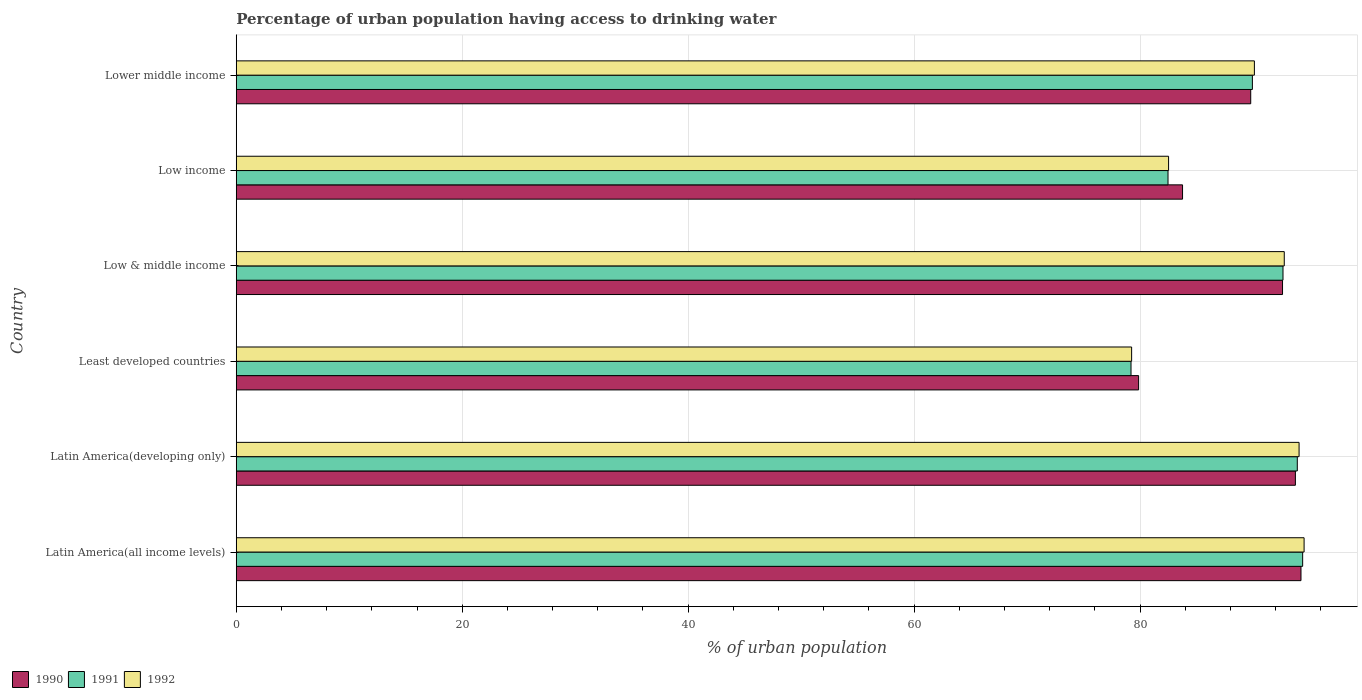How many different coloured bars are there?
Ensure brevity in your answer.  3. How many bars are there on the 3rd tick from the top?
Your answer should be very brief. 3. How many bars are there on the 6th tick from the bottom?
Give a very brief answer. 3. What is the label of the 5th group of bars from the top?
Your answer should be compact. Latin America(developing only). In how many cases, is the number of bars for a given country not equal to the number of legend labels?
Offer a very short reply. 0. What is the percentage of urban population having access to drinking water in 1991 in Latin America(developing only)?
Your answer should be very brief. 93.92. Across all countries, what is the maximum percentage of urban population having access to drinking water in 1991?
Your response must be concise. 94.39. Across all countries, what is the minimum percentage of urban population having access to drinking water in 1992?
Offer a very short reply. 79.25. In which country was the percentage of urban population having access to drinking water in 1991 maximum?
Your answer should be very brief. Latin America(all income levels). In which country was the percentage of urban population having access to drinking water in 1990 minimum?
Your answer should be compact. Least developed countries. What is the total percentage of urban population having access to drinking water in 1990 in the graph?
Provide a short and direct response. 534.02. What is the difference between the percentage of urban population having access to drinking water in 1990 in Least developed countries and that in Low income?
Ensure brevity in your answer.  -3.89. What is the difference between the percentage of urban population having access to drinking water in 1990 in Latin America(all income levels) and the percentage of urban population having access to drinking water in 1991 in Low income?
Provide a short and direct response. 11.77. What is the average percentage of urban population having access to drinking water in 1990 per country?
Your answer should be compact. 89. What is the difference between the percentage of urban population having access to drinking water in 1990 and percentage of urban population having access to drinking water in 1992 in Latin America(all income levels)?
Ensure brevity in your answer.  -0.28. In how many countries, is the percentage of urban population having access to drinking water in 1990 greater than 72 %?
Your response must be concise. 6. What is the ratio of the percentage of urban population having access to drinking water in 1990 in Low & middle income to that in Low income?
Provide a succinct answer. 1.11. Is the percentage of urban population having access to drinking water in 1992 in Latin America(all income levels) less than that in Latin America(developing only)?
Provide a short and direct response. No. What is the difference between the highest and the second highest percentage of urban population having access to drinking water in 1992?
Keep it short and to the point. 0.44. What is the difference between the highest and the lowest percentage of urban population having access to drinking water in 1991?
Keep it short and to the point. 15.19. Is the sum of the percentage of urban population having access to drinking water in 1991 in Latin America(developing only) and Low & middle income greater than the maximum percentage of urban population having access to drinking water in 1990 across all countries?
Keep it short and to the point. Yes. What does the 2nd bar from the top in Low income represents?
Your answer should be very brief. 1991. What does the 3rd bar from the bottom in Latin America(developing only) represents?
Make the answer very short. 1992. Are all the bars in the graph horizontal?
Give a very brief answer. Yes. How many countries are there in the graph?
Ensure brevity in your answer.  6. What is the difference between two consecutive major ticks on the X-axis?
Make the answer very short. 20. Where does the legend appear in the graph?
Offer a very short reply. Bottom left. How are the legend labels stacked?
Give a very brief answer. Horizontal. What is the title of the graph?
Ensure brevity in your answer.  Percentage of urban population having access to drinking water. What is the label or title of the X-axis?
Offer a terse response. % of urban population. What is the label or title of the Y-axis?
Your response must be concise. Country. What is the % of urban population of 1990 in Latin America(all income levels)?
Offer a very short reply. 94.24. What is the % of urban population of 1991 in Latin America(all income levels)?
Provide a short and direct response. 94.39. What is the % of urban population in 1992 in Latin America(all income levels)?
Provide a succinct answer. 94.52. What is the % of urban population in 1990 in Latin America(developing only)?
Make the answer very short. 93.75. What is the % of urban population of 1991 in Latin America(developing only)?
Your answer should be compact. 93.92. What is the % of urban population in 1992 in Latin America(developing only)?
Ensure brevity in your answer.  94.07. What is the % of urban population in 1990 in Least developed countries?
Your answer should be very brief. 79.87. What is the % of urban population in 1991 in Least developed countries?
Ensure brevity in your answer.  79.2. What is the % of urban population of 1992 in Least developed countries?
Your answer should be very brief. 79.25. What is the % of urban population in 1990 in Low & middle income?
Keep it short and to the point. 92.61. What is the % of urban population in 1991 in Low & middle income?
Give a very brief answer. 92.65. What is the % of urban population of 1992 in Low & middle income?
Your answer should be compact. 92.76. What is the % of urban population of 1990 in Low income?
Offer a terse response. 83.76. What is the % of urban population of 1991 in Low income?
Keep it short and to the point. 82.47. What is the % of urban population in 1992 in Low income?
Ensure brevity in your answer.  82.52. What is the % of urban population of 1990 in Lower middle income?
Provide a succinct answer. 89.79. What is the % of urban population in 1991 in Lower middle income?
Provide a succinct answer. 89.94. What is the % of urban population of 1992 in Lower middle income?
Provide a succinct answer. 90.12. Across all countries, what is the maximum % of urban population of 1990?
Your response must be concise. 94.24. Across all countries, what is the maximum % of urban population in 1991?
Provide a short and direct response. 94.39. Across all countries, what is the maximum % of urban population in 1992?
Ensure brevity in your answer.  94.52. Across all countries, what is the minimum % of urban population in 1990?
Offer a terse response. 79.87. Across all countries, what is the minimum % of urban population of 1991?
Provide a succinct answer. 79.2. Across all countries, what is the minimum % of urban population in 1992?
Your response must be concise. 79.25. What is the total % of urban population in 1990 in the graph?
Ensure brevity in your answer.  534.02. What is the total % of urban population of 1991 in the graph?
Your answer should be compact. 532.57. What is the total % of urban population in 1992 in the graph?
Give a very brief answer. 533.25. What is the difference between the % of urban population of 1990 in Latin America(all income levels) and that in Latin America(developing only)?
Ensure brevity in your answer.  0.49. What is the difference between the % of urban population of 1991 in Latin America(all income levels) and that in Latin America(developing only)?
Your answer should be very brief. 0.47. What is the difference between the % of urban population in 1992 in Latin America(all income levels) and that in Latin America(developing only)?
Your answer should be compact. 0.44. What is the difference between the % of urban population in 1990 in Latin America(all income levels) and that in Least developed countries?
Offer a terse response. 14.37. What is the difference between the % of urban population in 1991 in Latin America(all income levels) and that in Least developed countries?
Provide a succinct answer. 15.19. What is the difference between the % of urban population of 1992 in Latin America(all income levels) and that in Least developed countries?
Your response must be concise. 15.27. What is the difference between the % of urban population in 1990 in Latin America(all income levels) and that in Low & middle income?
Provide a succinct answer. 1.63. What is the difference between the % of urban population of 1991 in Latin America(all income levels) and that in Low & middle income?
Give a very brief answer. 1.74. What is the difference between the % of urban population in 1992 in Latin America(all income levels) and that in Low & middle income?
Provide a succinct answer. 1.76. What is the difference between the % of urban population in 1990 in Latin America(all income levels) and that in Low income?
Your answer should be compact. 10.48. What is the difference between the % of urban population in 1991 in Latin America(all income levels) and that in Low income?
Provide a succinct answer. 11.92. What is the difference between the % of urban population of 1992 in Latin America(all income levels) and that in Low income?
Provide a short and direct response. 12. What is the difference between the % of urban population of 1990 in Latin America(all income levels) and that in Lower middle income?
Offer a terse response. 4.45. What is the difference between the % of urban population of 1991 in Latin America(all income levels) and that in Lower middle income?
Your answer should be very brief. 4.45. What is the difference between the % of urban population in 1992 in Latin America(all income levels) and that in Lower middle income?
Make the answer very short. 4.4. What is the difference between the % of urban population of 1990 in Latin America(developing only) and that in Least developed countries?
Your answer should be very brief. 13.88. What is the difference between the % of urban population of 1991 in Latin America(developing only) and that in Least developed countries?
Your answer should be very brief. 14.72. What is the difference between the % of urban population in 1992 in Latin America(developing only) and that in Least developed countries?
Offer a terse response. 14.82. What is the difference between the % of urban population in 1990 in Latin America(developing only) and that in Low & middle income?
Provide a succinct answer. 1.14. What is the difference between the % of urban population of 1991 in Latin America(developing only) and that in Low & middle income?
Ensure brevity in your answer.  1.27. What is the difference between the % of urban population in 1992 in Latin America(developing only) and that in Low & middle income?
Keep it short and to the point. 1.31. What is the difference between the % of urban population in 1990 in Latin America(developing only) and that in Low income?
Your answer should be very brief. 9.99. What is the difference between the % of urban population of 1991 in Latin America(developing only) and that in Low income?
Your answer should be compact. 11.44. What is the difference between the % of urban population of 1992 in Latin America(developing only) and that in Low income?
Ensure brevity in your answer.  11.55. What is the difference between the % of urban population of 1990 in Latin America(developing only) and that in Lower middle income?
Your answer should be very brief. 3.95. What is the difference between the % of urban population in 1991 in Latin America(developing only) and that in Lower middle income?
Your answer should be very brief. 3.97. What is the difference between the % of urban population of 1992 in Latin America(developing only) and that in Lower middle income?
Provide a short and direct response. 3.96. What is the difference between the % of urban population in 1990 in Least developed countries and that in Low & middle income?
Provide a short and direct response. -12.74. What is the difference between the % of urban population in 1991 in Least developed countries and that in Low & middle income?
Your answer should be compact. -13.45. What is the difference between the % of urban population of 1992 in Least developed countries and that in Low & middle income?
Provide a succinct answer. -13.51. What is the difference between the % of urban population in 1990 in Least developed countries and that in Low income?
Your answer should be compact. -3.89. What is the difference between the % of urban population of 1991 in Least developed countries and that in Low income?
Your answer should be compact. -3.28. What is the difference between the % of urban population of 1992 in Least developed countries and that in Low income?
Provide a short and direct response. -3.27. What is the difference between the % of urban population of 1990 in Least developed countries and that in Lower middle income?
Offer a very short reply. -9.92. What is the difference between the % of urban population of 1991 in Least developed countries and that in Lower middle income?
Give a very brief answer. -10.74. What is the difference between the % of urban population in 1992 in Least developed countries and that in Lower middle income?
Give a very brief answer. -10.87. What is the difference between the % of urban population of 1990 in Low & middle income and that in Low income?
Keep it short and to the point. 8.85. What is the difference between the % of urban population of 1991 in Low & middle income and that in Low income?
Provide a succinct answer. 10.18. What is the difference between the % of urban population of 1992 in Low & middle income and that in Low income?
Provide a succinct answer. 10.24. What is the difference between the % of urban population in 1990 in Low & middle income and that in Lower middle income?
Ensure brevity in your answer.  2.82. What is the difference between the % of urban population of 1991 in Low & middle income and that in Lower middle income?
Provide a succinct answer. 2.71. What is the difference between the % of urban population in 1992 in Low & middle income and that in Lower middle income?
Offer a terse response. 2.64. What is the difference between the % of urban population of 1990 in Low income and that in Lower middle income?
Provide a succinct answer. -6.03. What is the difference between the % of urban population of 1991 in Low income and that in Lower middle income?
Make the answer very short. -7.47. What is the difference between the % of urban population of 1992 in Low income and that in Lower middle income?
Keep it short and to the point. -7.6. What is the difference between the % of urban population of 1990 in Latin America(all income levels) and the % of urban population of 1991 in Latin America(developing only)?
Make the answer very short. 0.33. What is the difference between the % of urban population in 1990 in Latin America(all income levels) and the % of urban population in 1992 in Latin America(developing only)?
Make the answer very short. 0.17. What is the difference between the % of urban population in 1991 in Latin America(all income levels) and the % of urban population in 1992 in Latin America(developing only)?
Give a very brief answer. 0.32. What is the difference between the % of urban population in 1990 in Latin America(all income levels) and the % of urban population in 1991 in Least developed countries?
Ensure brevity in your answer.  15.04. What is the difference between the % of urban population in 1990 in Latin America(all income levels) and the % of urban population in 1992 in Least developed countries?
Give a very brief answer. 14.99. What is the difference between the % of urban population of 1991 in Latin America(all income levels) and the % of urban population of 1992 in Least developed countries?
Your answer should be compact. 15.14. What is the difference between the % of urban population of 1990 in Latin America(all income levels) and the % of urban population of 1991 in Low & middle income?
Provide a succinct answer. 1.59. What is the difference between the % of urban population of 1990 in Latin America(all income levels) and the % of urban population of 1992 in Low & middle income?
Provide a short and direct response. 1.48. What is the difference between the % of urban population of 1991 in Latin America(all income levels) and the % of urban population of 1992 in Low & middle income?
Make the answer very short. 1.63. What is the difference between the % of urban population in 1990 in Latin America(all income levels) and the % of urban population in 1991 in Low income?
Your response must be concise. 11.77. What is the difference between the % of urban population in 1990 in Latin America(all income levels) and the % of urban population in 1992 in Low income?
Provide a short and direct response. 11.72. What is the difference between the % of urban population of 1991 in Latin America(all income levels) and the % of urban population of 1992 in Low income?
Your response must be concise. 11.87. What is the difference between the % of urban population in 1990 in Latin America(all income levels) and the % of urban population in 1991 in Lower middle income?
Your answer should be very brief. 4.3. What is the difference between the % of urban population of 1990 in Latin America(all income levels) and the % of urban population of 1992 in Lower middle income?
Provide a succinct answer. 4.12. What is the difference between the % of urban population of 1991 in Latin America(all income levels) and the % of urban population of 1992 in Lower middle income?
Your response must be concise. 4.27. What is the difference between the % of urban population of 1990 in Latin America(developing only) and the % of urban population of 1991 in Least developed countries?
Your answer should be compact. 14.55. What is the difference between the % of urban population of 1990 in Latin America(developing only) and the % of urban population of 1992 in Least developed countries?
Make the answer very short. 14.5. What is the difference between the % of urban population in 1991 in Latin America(developing only) and the % of urban population in 1992 in Least developed countries?
Provide a succinct answer. 14.66. What is the difference between the % of urban population of 1990 in Latin America(developing only) and the % of urban population of 1991 in Low & middle income?
Offer a very short reply. 1.1. What is the difference between the % of urban population of 1990 in Latin America(developing only) and the % of urban population of 1992 in Low & middle income?
Provide a succinct answer. 0.99. What is the difference between the % of urban population in 1991 in Latin America(developing only) and the % of urban population in 1992 in Low & middle income?
Ensure brevity in your answer.  1.15. What is the difference between the % of urban population in 1990 in Latin America(developing only) and the % of urban population in 1991 in Low income?
Ensure brevity in your answer.  11.27. What is the difference between the % of urban population in 1990 in Latin America(developing only) and the % of urban population in 1992 in Low income?
Ensure brevity in your answer.  11.23. What is the difference between the % of urban population in 1991 in Latin America(developing only) and the % of urban population in 1992 in Low income?
Offer a terse response. 11.39. What is the difference between the % of urban population in 1990 in Latin America(developing only) and the % of urban population in 1991 in Lower middle income?
Provide a short and direct response. 3.81. What is the difference between the % of urban population of 1990 in Latin America(developing only) and the % of urban population of 1992 in Lower middle income?
Offer a very short reply. 3.63. What is the difference between the % of urban population of 1991 in Latin America(developing only) and the % of urban population of 1992 in Lower middle income?
Give a very brief answer. 3.8. What is the difference between the % of urban population of 1990 in Least developed countries and the % of urban population of 1991 in Low & middle income?
Offer a terse response. -12.78. What is the difference between the % of urban population of 1990 in Least developed countries and the % of urban population of 1992 in Low & middle income?
Ensure brevity in your answer.  -12.89. What is the difference between the % of urban population in 1991 in Least developed countries and the % of urban population in 1992 in Low & middle income?
Provide a succinct answer. -13.56. What is the difference between the % of urban population in 1990 in Least developed countries and the % of urban population in 1991 in Low income?
Offer a terse response. -2.6. What is the difference between the % of urban population of 1990 in Least developed countries and the % of urban population of 1992 in Low income?
Offer a terse response. -2.65. What is the difference between the % of urban population of 1991 in Least developed countries and the % of urban population of 1992 in Low income?
Your answer should be very brief. -3.32. What is the difference between the % of urban population in 1990 in Least developed countries and the % of urban population in 1991 in Lower middle income?
Your response must be concise. -10.07. What is the difference between the % of urban population in 1990 in Least developed countries and the % of urban population in 1992 in Lower middle income?
Your answer should be very brief. -10.25. What is the difference between the % of urban population of 1991 in Least developed countries and the % of urban population of 1992 in Lower middle income?
Keep it short and to the point. -10.92. What is the difference between the % of urban population in 1990 in Low & middle income and the % of urban population in 1991 in Low income?
Offer a very short reply. 10.14. What is the difference between the % of urban population of 1990 in Low & middle income and the % of urban population of 1992 in Low income?
Your answer should be compact. 10.09. What is the difference between the % of urban population of 1991 in Low & middle income and the % of urban population of 1992 in Low income?
Offer a terse response. 10.13. What is the difference between the % of urban population in 1990 in Low & middle income and the % of urban population in 1991 in Lower middle income?
Provide a succinct answer. 2.67. What is the difference between the % of urban population of 1990 in Low & middle income and the % of urban population of 1992 in Lower middle income?
Your response must be concise. 2.49. What is the difference between the % of urban population of 1991 in Low & middle income and the % of urban population of 1992 in Lower middle income?
Ensure brevity in your answer.  2.53. What is the difference between the % of urban population in 1990 in Low income and the % of urban population in 1991 in Lower middle income?
Your answer should be compact. -6.18. What is the difference between the % of urban population of 1990 in Low income and the % of urban population of 1992 in Lower middle income?
Offer a terse response. -6.36. What is the difference between the % of urban population in 1991 in Low income and the % of urban population in 1992 in Lower middle income?
Your answer should be very brief. -7.64. What is the average % of urban population in 1990 per country?
Keep it short and to the point. 89. What is the average % of urban population in 1991 per country?
Offer a terse response. 88.76. What is the average % of urban population in 1992 per country?
Provide a succinct answer. 88.87. What is the difference between the % of urban population of 1990 and % of urban population of 1991 in Latin America(all income levels)?
Your answer should be compact. -0.15. What is the difference between the % of urban population in 1990 and % of urban population in 1992 in Latin America(all income levels)?
Your response must be concise. -0.28. What is the difference between the % of urban population in 1991 and % of urban population in 1992 in Latin America(all income levels)?
Make the answer very short. -0.13. What is the difference between the % of urban population in 1990 and % of urban population in 1991 in Latin America(developing only)?
Your response must be concise. -0.17. What is the difference between the % of urban population in 1990 and % of urban population in 1992 in Latin America(developing only)?
Provide a short and direct response. -0.33. What is the difference between the % of urban population in 1991 and % of urban population in 1992 in Latin America(developing only)?
Keep it short and to the point. -0.16. What is the difference between the % of urban population in 1990 and % of urban population in 1991 in Least developed countries?
Your response must be concise. 0.67. What is the difference between the % of urban population in 1990 and % of urban population in 1992 in Least developed countries?
Provide a short and direct response. 0.62. What is the difference between the % of urban population in 1991 and % of urban population in 1992 in Least developed countries?
Provide a short and direct response. -0.05. What is the difference between the % of urban population of 1990 and % of urban population of 1991 in Low & middle income?
Give a very brief answer. -0.04. What is the difference between the % of urban population of 1990 and % of urban population of 1992 in Low & middle income?
Give a very brief answer. -0.15. What is the difference between the % of urban population in 1991 and % of urban population in 1992 in Low & middle income?
Your answer should be compact. -0.11. What is the difference between the % of urban population in 1990 and % of urban population in 1991 in Low income?
Keep it short and to the point. 1.29. What is the difference between the % of urban population in 1990 and % of urban population in 1992 in Low income?
Ensure brevity in your answer.  1.24. What is the difference between the % of urban population in 1991 and % of urban population in 1992 in Low income?
Your answer should be very brief. -0.05. What is the difference between the % of urban population of 1990 and % of urban population of 1991 in Lower middle income?
Offer a terse response. -0.15. What is the difference between the % of urban population of 1990 and % of urban population of 1992 in Lower middle income?
Your answer should be compact. -0.33. What is the difference between the % of urban population of 1991 and % of urban population of 1992 in Lower middle income?
Your answer should be compact. -0.18. What is the ratio of the % of urban population in 1991 in Latin America(all income levels) to that in Latin America(developing only)?
Keep it short and to the point. 1.01. What is the ratio of the % of urban population in 1992 in Latin America(all income levels) to that in Latin America(developing only)?
Your response must be concise. 1. What is the ratio of the % of urban population of 1990 in Latin America(all income levels) to that in Least developed countries?
Offer a terse response. 1.18. What is the ratio of the % of urban population in 1991 in Latin America(all income levels) to that in Least developed countries?
Your response must be concise. 1.19. What is the ratio of the % of urban population of 1992 in Latin America(all income levels) to that in Least developed countries?
Provide a succinct answer. 1.19. What is the ratio of the % of urban population of 1990 in Latin America(all income levels) to that in Low & middle income?
Provide a succinct answer. 1.02. What is the ratio of the % of urban population of 1991 in Latin America(all income levels) to that in Low & middle income?
Your answer should be very brief. 1.02. What is the ratio of the % of urban population of 1992 in Latin America(all income levels) to that in Low & middle income?
Your answer should be compact. 1.02. What is the ratio of the % of urban population in 1990 in Latin America(all income levels) to that in Low income?
Give a very brief answer. 1.13. What is the ratio of the % of urban population in 1991 in Latin America(all income levels) to that in Low income?
Keep it short and to the point. 1.14. What is the ratio of the % of urban population of 1992 in Latin America(all income levels) to that in Low income?
Offer a terse response. 1.15. What is the ratio of the % of urban population of 1990 in Latin America(all income levels) to that in Lower middle income?
Make the answer very short. 1.05. What is the ratio of the % of urban population in 1991 in Latin America(all income levels) to that in Lower middle income?
Offer a terse response. 1.05. What is the ratio of the % of urban population of 1992 in Latin America(all income levels) to that in Lower middle income?
Ensure brevity in your answer.  1.05. What is the ratio of the % of urban population of 1990 in Latin America(developing only) to that in Least developed countries?
Provide a short and direct response. 1.17. What is the ratio of the % of urban population in 1991 in Latin America(developing only) to that in Least developed countries?
Ensure brevity in your answer.  1.19. What is the ratio of the % of urban population of 1992 in Latin America(developing only) to that in Least developed countries?
Provide a succinct answer. 1.19. What is the ratio of the % of urban population in 1990 in Latin America(developing only) to that in Low & middle income?
Offer a very short reply. 1.01. What is the ratio of the % of urban population in 1991 in Latin America(developing only) to that in Low & middle income?
Your answer should be compact. 1.01. What is the ratio of the % of urban population in 1992 in Latin America(developing only) to that in Low & middle income?
Your answer should be very brief. 1.01. What is the ratio of the % of urban population of 1990 in Latin America(developing only) to that in Low income?
Your answer should be very brief. 1.12. What is the ratio of the % of urban population in 1991 in Latin America(developing only) to that in Low income?
Provide a short and direct response. 1.14. What is the ratio of the % of urban population in 1992 in Latin America(developing only) to that in Low income?
Keep it short and to the point. 1.14. What is the ratio of the % of urban population of 1990 in Latin America(developing only) to that in Lower middle income?
Your answer should be very brief. 1.04. What is the ratio of the % of urban population in 1991 in Latin America(developing only) to that in Lower middle income?
Offer a terse response. 1.04. What is the ratio of the % of urban population of 1992 in Latin America(developing only) to that in Lower middle income?
Ensure brevity in your answer.  1.04. What is the ratio of the % of urban population in 1990 in Least developed countries to that in Low & middle income?
Your response must be concise. 0.86. What is the ratio of the % of urban population of 1991 in Least developed countries to that in Low & middle income?
Keep it short and to the point. 0.85. What is the ratio of the % of urban population in 1992 in Least developed countries to that in Low & middle income?
Keep it short and to the point. 0.85. What is the ratio of the % of urban population of 1990 in Least developed countries to that in Low income?
Your answer should be very brief. 0.95. What is the ratio of the % of urban population in 1991 in Least developed countries to that in Low income?
Give a very brief answer. 0.96. What is the ratio of the % of urban population of 1992 in Least developed countries to that in Low income?
Provide a short and direct response. 0.96. What is the ratio of the % of urban population of 1990 in Least developed countries to that in Lower middle income?
Keep it short and to the point. 0.89. What is the ratio of the % of urban population in 1991 in Least developed countries to that in Lower middle income?
Ensure brevity in your answer.  0.88. What is the ratio of the % of urban population of 1992 in Least developed countries to that in Lower middle income?
Your answer should be compact. 0.88. What is the ratio of the % of urban population in 1990 in Low & middle income to that in Low income?
Your answer should be compact. 1.11. What is the ratio of the % of urban population in 1991 in Low & middle income to that in Low income?
Offer a very short reply. 1.12. What is the ratio of the % of urban population in 1992 in Low & middle income to that in Low income?
Ensure brevity in your answer.  1.12. What is the ratio of the % of urban population of 1990 in Low & middle income to that in Lower middle income?
Offer a terse response. 1.03. What is the ratio of the % of urban population of 1991 in Low & middle income to that in Lower middle income?
Offer a terse response. 1.03. What is the ratio of the % of urban population in 1992 in Low & middle income to that in Lower middle income?
Your answer should be very brief. 1.03. What is the ratio of the % of urban population of 1990 in Low income to that in Lower middle income?
Your answer should be very brief. 0.93. What is the ratio of the % of urban population of 1991 in Low income to that in Lower middle income?
Your answer should be compact. 0.92. What is the ratio of the % of urban population of 1992 in Low income to that in Lower middle income?
Provide a succinct answer. 0.92. What is the difference between the highest and the second highest % of urban population in 1990?
Your answer should be compact. 0.49. What is the difference between the highest and the second highest % of urban population in 1991?
Offer a very short reply. 0.47. What is the difference between the highest and the second highest % of urban population in 1992?
Provide a short and direct response. 0.44. What is the difference between the highest and the lowest % of urban population in 1990?
Your answer should be compact. 14.37. What is the difference between the highest and the lowest % of urban population of 1991?
Give a very brief answer. 15.19. What is the difference between the highest and the lowest % of urban population in 1992?
Make the answer very short. 15.27. 